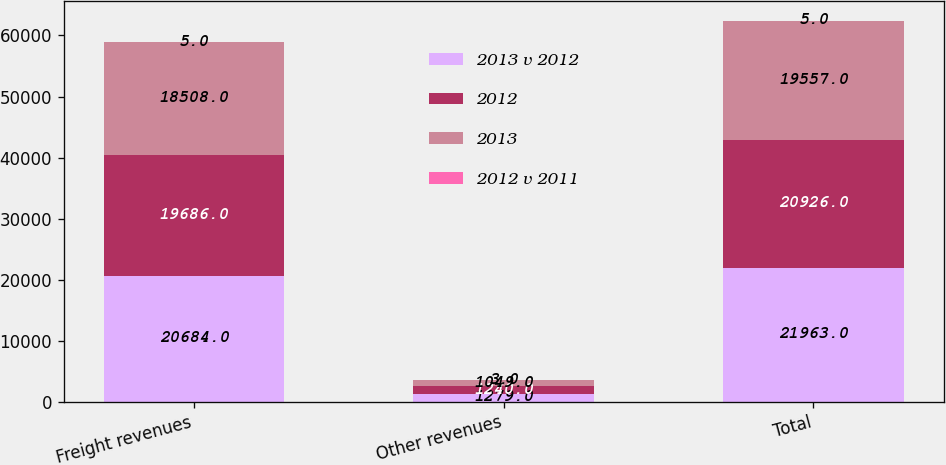Convert chart to OTSL. <chart><loc_0><loc_0><loc_500><loc_500><stacked_bar_chart><ecel><fcel>Freight revenues<fcel>Other revenues<fcel>Total<nl><fcel>2013 v 2012<fcel>20684<fcel>1279<fcel>21963<nl><fcel>2012<fcel>19686<fcel>1240<fcel>20926<nl><fcel>2013<fcel>18508<fcel>1049<fcel>19557<nl><fcel>2012 v 2011<fcel>5<fcel>3<fcel>5<nl></chart> 